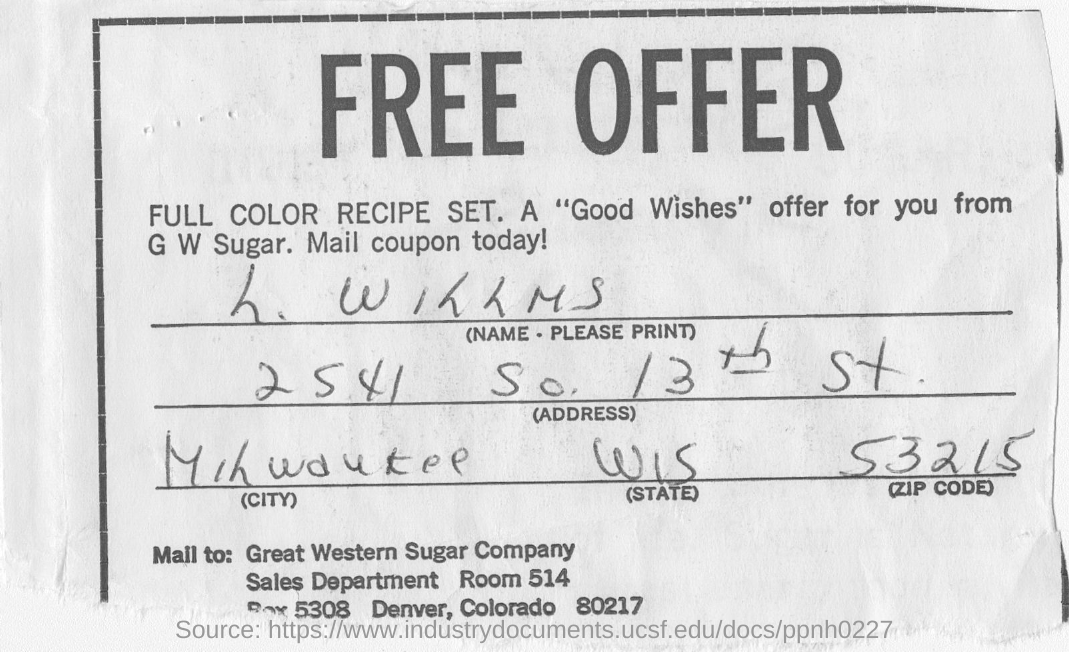Identify some key points in this picture. The mail is to be sent to Great Western Sugar Company. The zip code listed on the receipt is 53215. The receipt indicates that the address given is 2541 SO. 13TH ST.. The receipt mentions the name "L. WILLMS. 